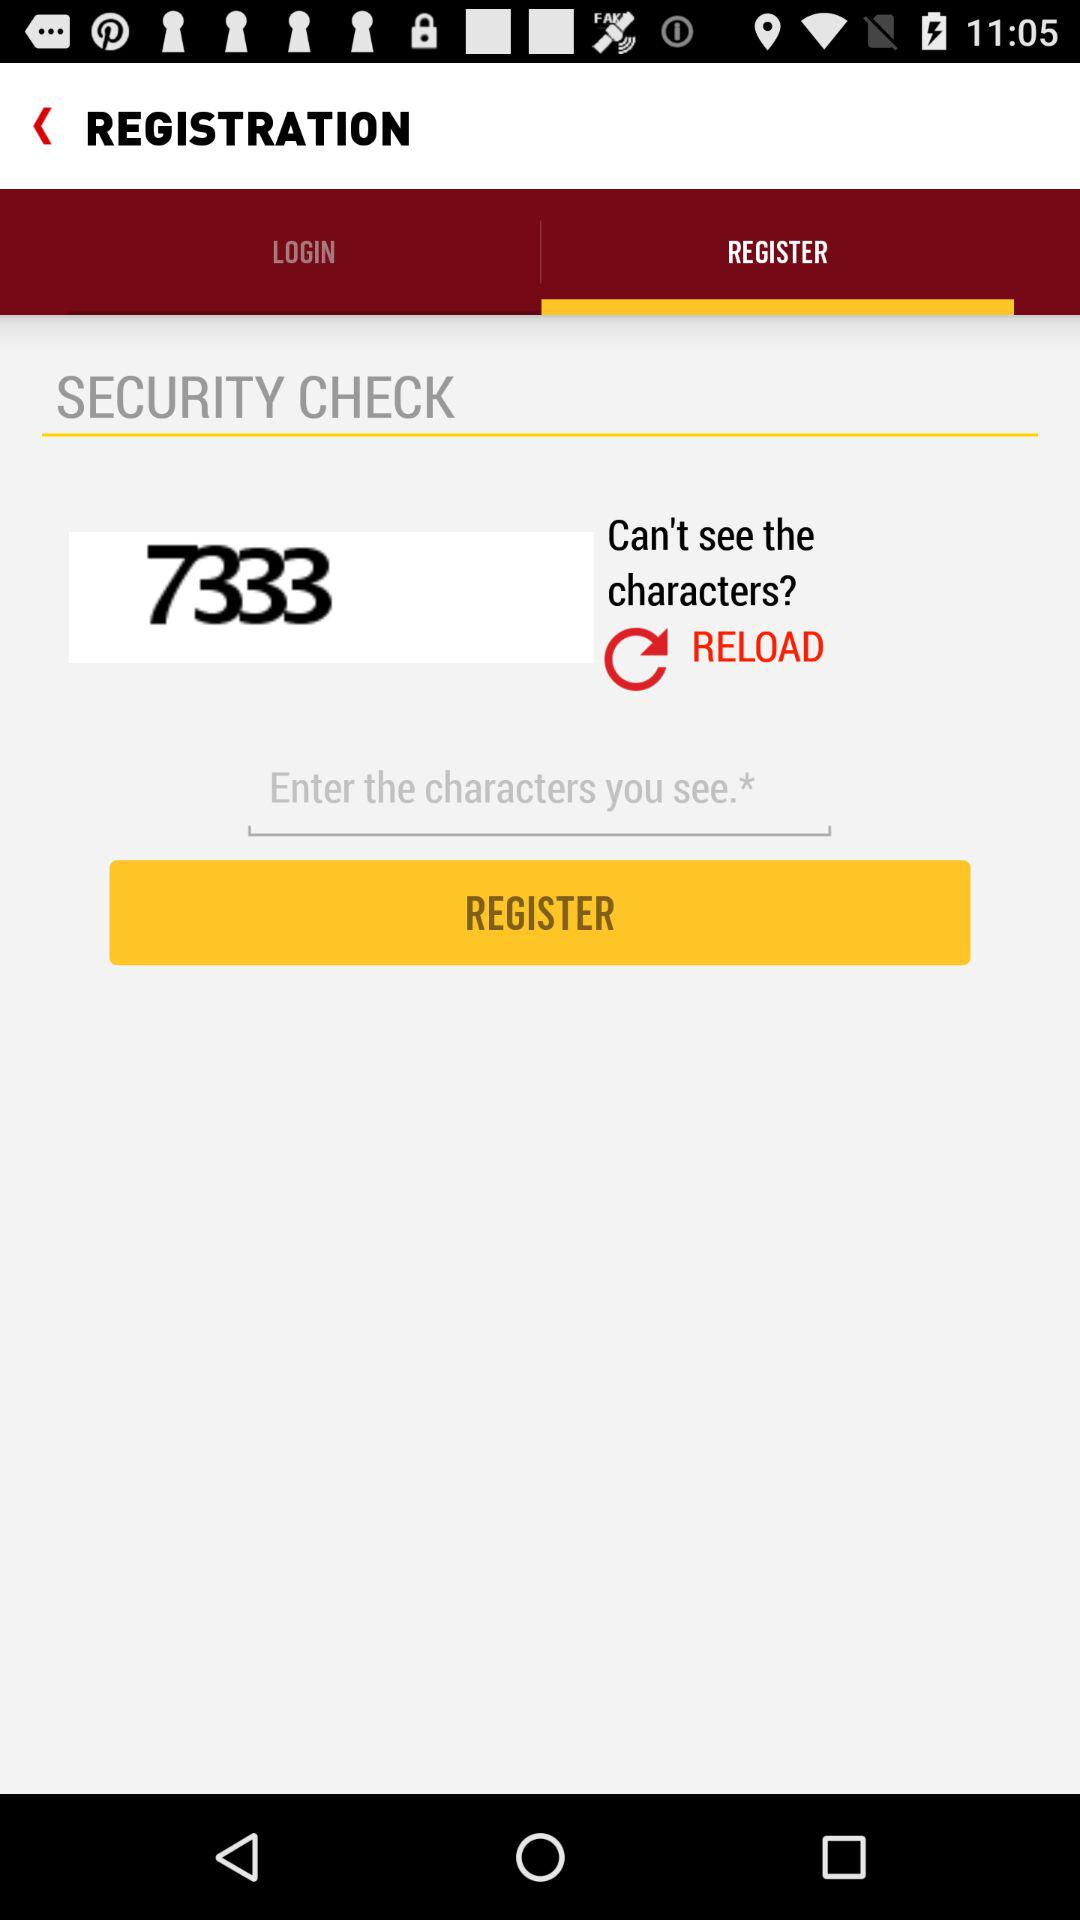What is the number in the security check box? The number is 7333. 